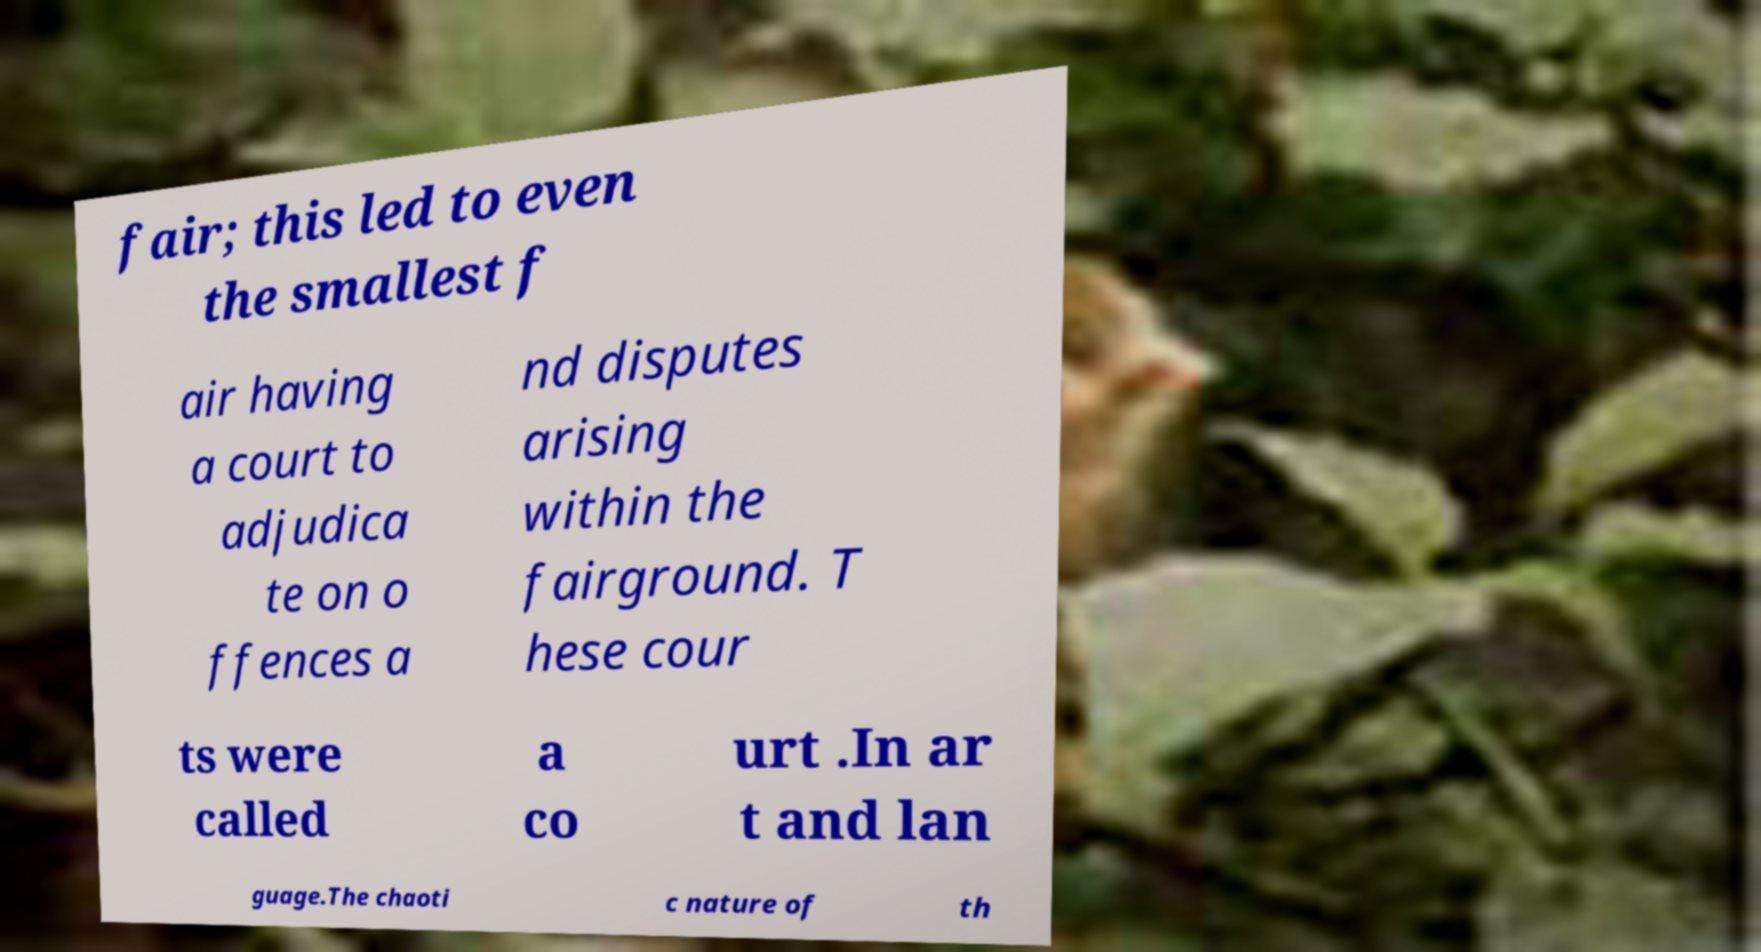Could you assist in decoding the text presented in this image and type it out clearly? fair; this led to even the smallest f air having a court to adjudica te on o ffences a nd disputes arising within the fairground. T hese cour ts were called a co urt .In ar t and lan guage.The chaoti c nature of th 